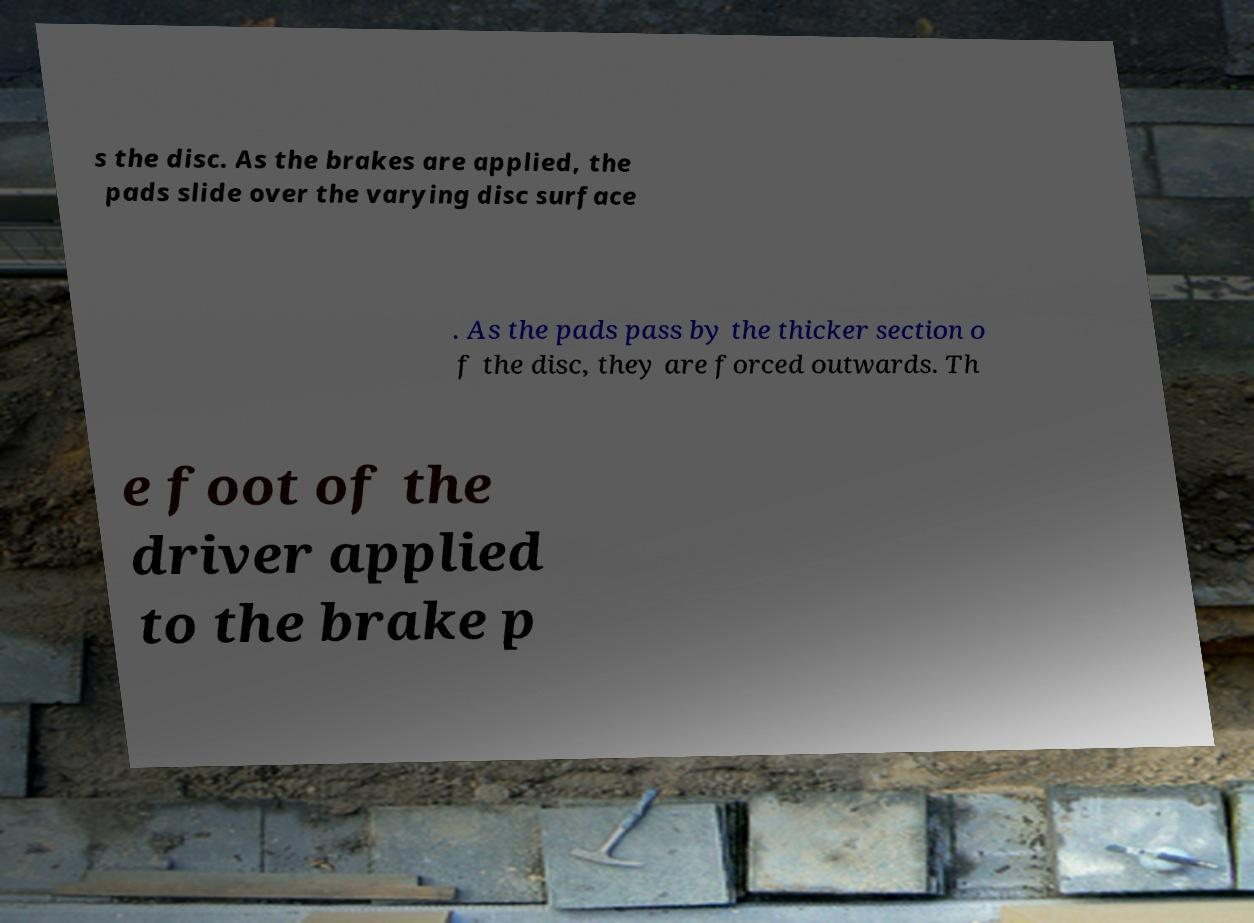Can you accurately transcribe the text from the provided image for me? s the disc. As the brakes are applied, the pads slide over the varying disc surface . As the pads pass by the thicker section o f the disc, they are forced outwards. Th e foot of the driver applied to the brake p 